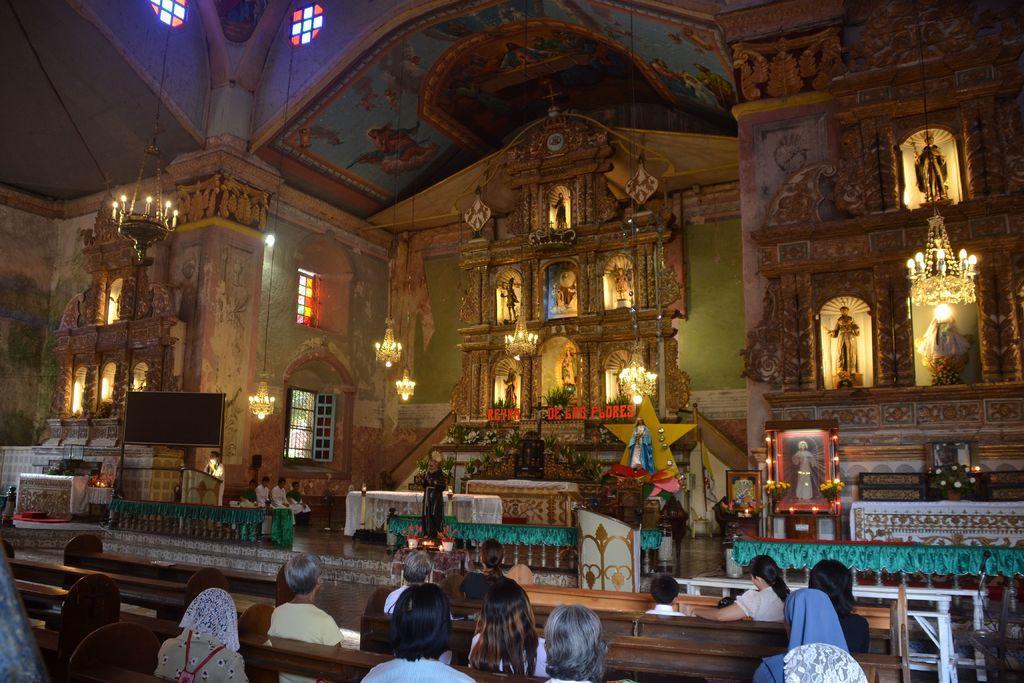Could you give a brief overview of what you see in this image? There are group of people sitting on the benches. Here is a person standing. These are the tables covered with the clothes. I think this picture was taken inside the church. These are the lamps with candles are hanging to the roof. I think these are the windows. I can see the sculptures. This looks like a frame. I think this is the screen, which is black in color. 